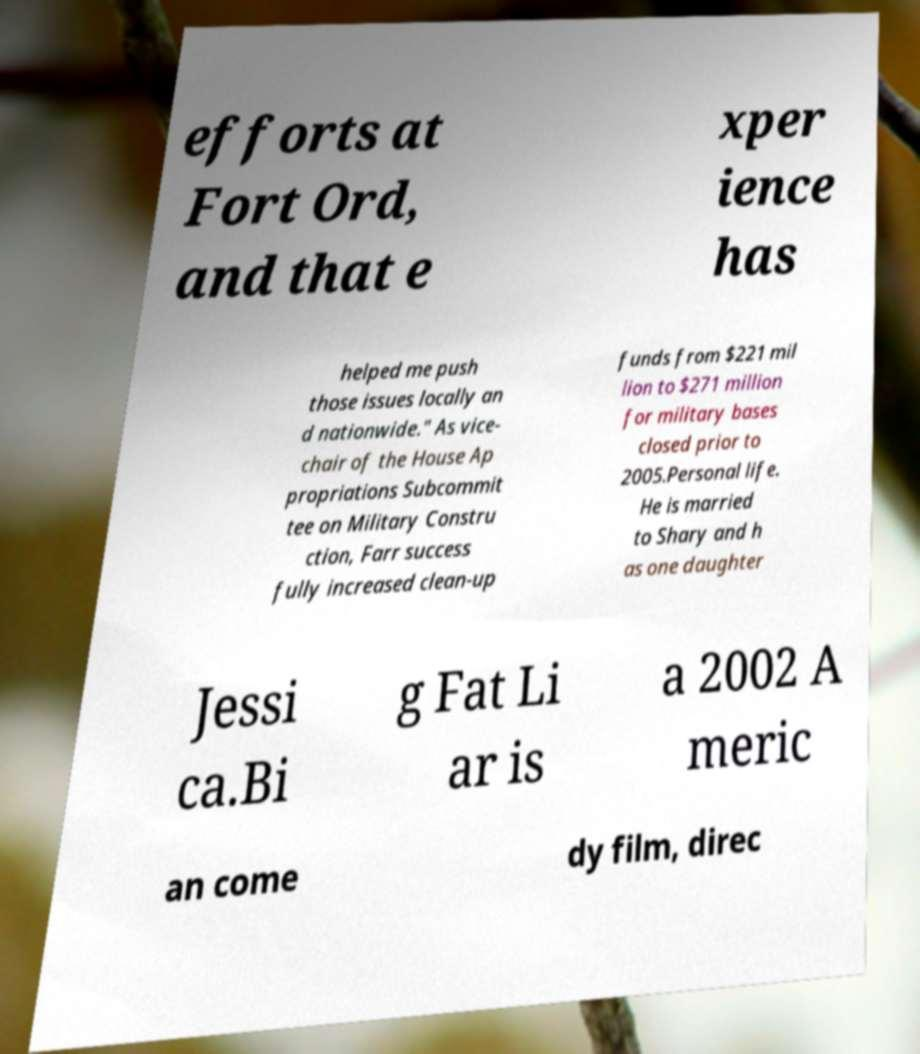There's text embedded in this image that I need extracted. Can you transcribe it verbatim? efforts at Fort Ord, and that e xper ience has helped me push those issues locally an d nationwide." As vice- chair of the House Ap propriations Subcommit tee on Military Constru ction, Farr success fully increased clean-up funds from $221 mil lion to $271 million for military bases closed prior to 2005.Personal life. He is married to Shary and h as one daughter Jessi ca.Bi g Fat Li ar is a 2002 A meric an come dy film, direc 